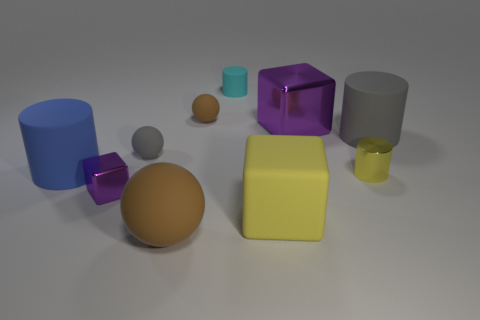Can you imagine a story where these objects are characters? Certainly! Imagine a world where geometric shapes are sentient beings. The blue cylinder could be 'Cylinda,' who loves to roll around and believes in unity since all points are equidistant from her center. 'Sphereo,' the brown sphere, could be the traveler, rolling through landscapes. The purple cube, 'Translucia,' might be considered the wise one, offering clear yet profound insights. 'Cubert,' the yellow cube, is all about stability and fairness, ensuring everyone has an equal side of the story. Lastly, 'Greyson,' the grey cylinder, is the mediator, bridging the gap between the rolling spheres and stable cubes. Together, they could embark on adventures that teach children about their shapes and properties while imparting moral lessons along the way. 